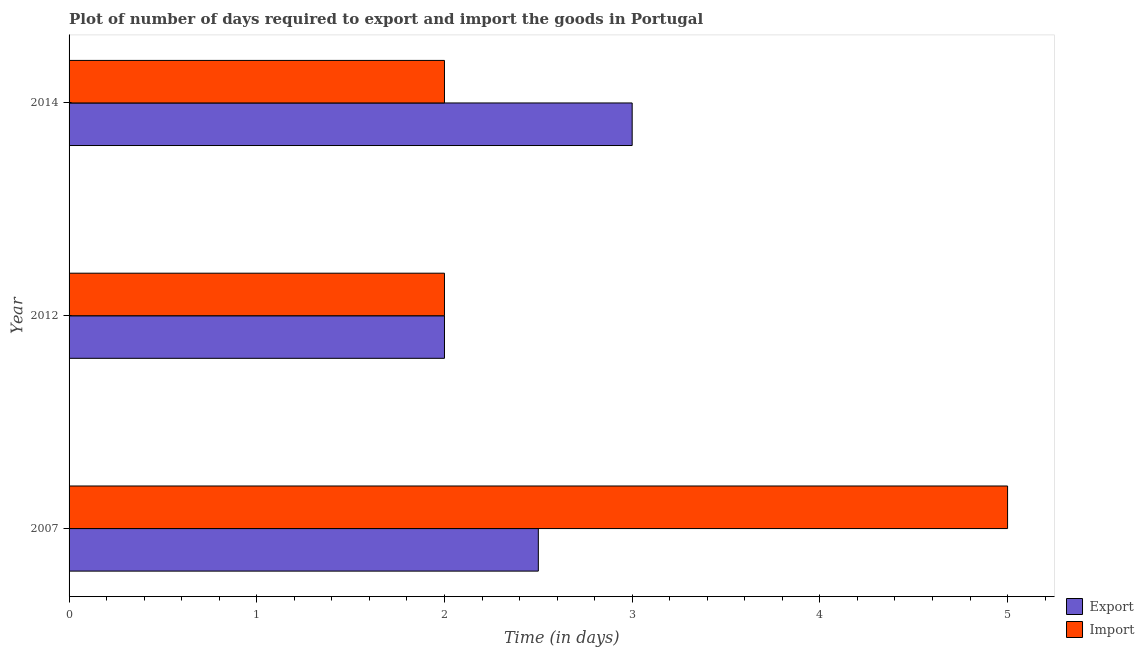How many groups of bars are there?
Your answer should be compact. 3. Are the number of bars per tick equal to the number of legend labels?
Your answer should be compact. Yes. How many bars are there on the 1st tick from the top?
Offer a very short reply. 2. How many bars are there on the 3rd tick from the bottom?
Your answer should be very brief. 2. What is the label of the 3rd group of bars from the top?
Offer a very short reply. 2007. What is the time required to export in 2014?
Your response must be concise. 3. Across all years, what is the maximum time required to export?
Provide a succinct answer. 3. Across all years, what is the minimum time required to import?
Keep it short and to the point. 2. What is the total time required to import in the graph?
Offer a terse response. 9. What is the difference between the time required to import in 2007 and that in 2012?
Offer a very short reply. 3. What is the difference between the time required to import in 2007 and the time required to export in 2012?
Your answer should be very brief. 3. What is the average time required to export per year?
Provide a short and direct response. 2.5. In the year 2012, what is the difference between the time required to export and time required to import?
Provide a succinct answer. 0. In how many years, is the time required to import greater than 2.6 days?
Ensure brevity in your answer.  1. What is the difference between the highest and the second highest time required to export?
Ensure brevity in your answer.  0.5. What is the difference between the highest and the lowest time required to import?
Offer a terse response. 3. What does the 2nd bar from the top in 2014 represents?
Provide a succinct answer. Export. What does the 1st bar from the bottom in 2014 represents?
Provide a succinct answer. Export. Are all the bars in the graph horizontal?
Your response must be concise. Yes. Does the graph contain grids?
Ensure brevity in your answer.  No. Where does the legend appear in the graph?
Keep it short and to the point. Bottom right. How many legend labels are there?
Your response must be concise. 2. What is the title of the graph?
Offer a very short reply. Plot of number of days required to export and import the goods in Portugal. What is the label or title of the X-axis?
Make the answer very short. Time (in days). What is the Time (in days) of Import in 2007?
Keep it short and to the point. 5. What is the Time (in days) in Import in 2012?
Your answer should be compact. 2. What is the Time (in days) in Export in 2014?
Ensure brevity in your answer.  3. Across all years, what is the maximum Time (in days) in Export?
Your response must be concise. 3. Across all years, what is the minimum Time (in days) in Import?
Make the answer very short. 2. What is the total Time (in days) in Export in the graph?
Make the answer very short. 7.5. What is the difference between the Time (in days) of Export in 2012 and that in 2014?
Ensure brevity in your answer.  -1. What is the difference between the Time (in days) in Import in 2012 and that in 2014?
Your answer should be very brief. 0. What is the difference between the Time (in days) in Export in 2007 and the Time (in days) in Import in 2012?
Give a very brief answer. 0.5. What is the difference between the Time (in days) of Export in 2007 and the Time (in days) of Import in 2014?
Provide a succinct answer. 0.5. What is the average Time (in days) of Export per year?
Your answer should be very brief. 2.5. In the year 2012, what is the difference between the Time (in days) of Export and Time (in days) of Import?
Give a very brief answer. 0. What is the ratio of the Time (in days) of Import in 2007 to that in 2014?
Provide a short and direct response. 2.5. What is the ratio of the Time (in days) of Export in 2012 to that in 2014?
Offer a very short reply. 0.67. What is the ratio of the Time (in days) of Import in 2012 to that in 2014?
Provide a succinct answer. 1. What is the difference between the highest and the lowest Time (in days) in Export?
Your answer should be compact. 1. 